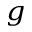<formula> <loc_0><loc_0><loc_500><loc_500>_ { g }</formula> 